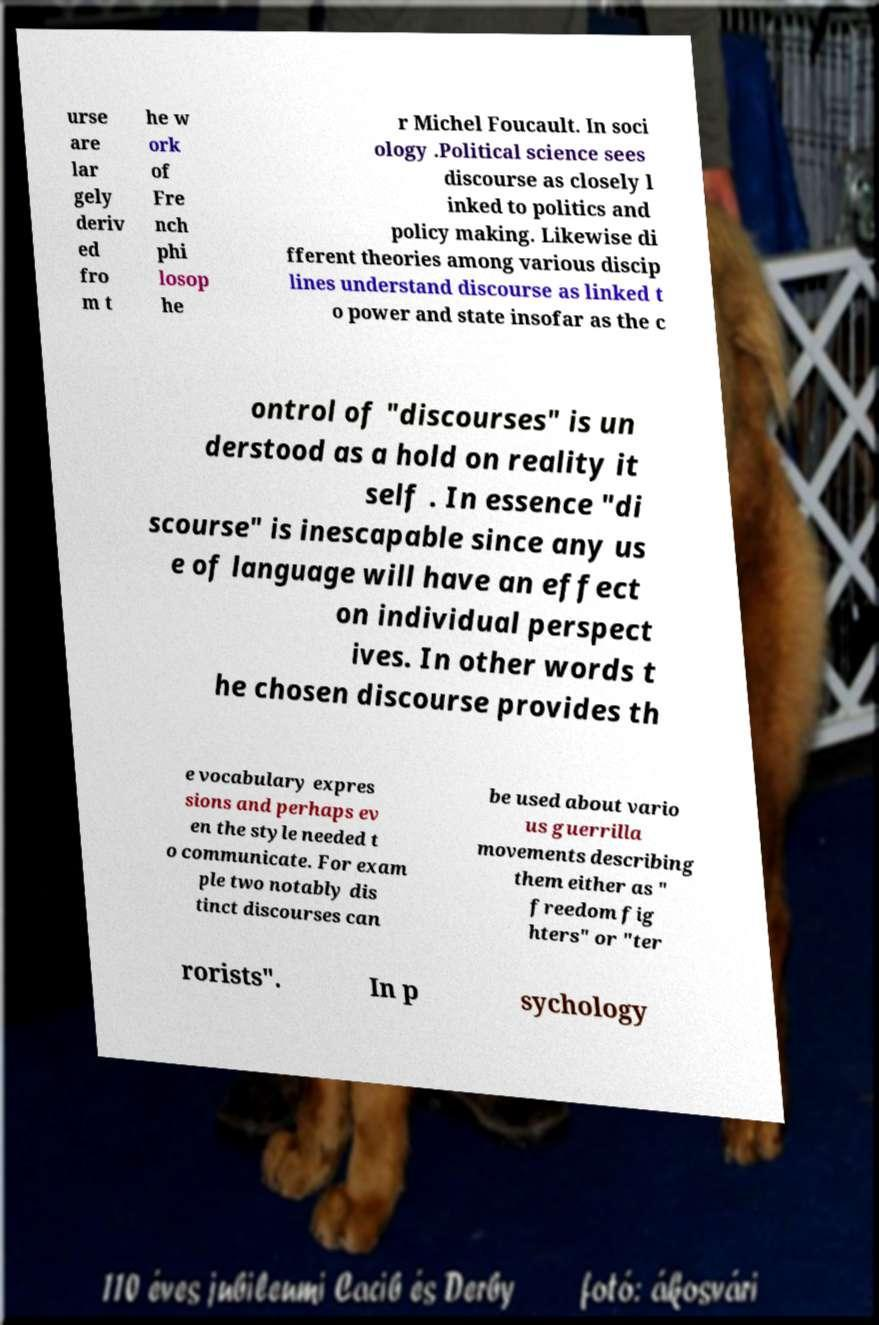Please read and relay the text visible in this image. What does it say? urse are lar gely deriv ed fro m t he w ork of Fre nch phi losop he r Michel Foucault. In soci ology .Political science sees discourse as closely l inked to politics and policy making. Likewise di fferent theories among various discip lines understand discourse as linked t o power and state insofar as the c ontrol of "discourses" is un derstood as a hold on reality it self . In essence "di scourse" is inescapable since any us e of language will have an effect on individual perspect ives. In other words t he chosen discourse provides th e vocabulary expres sions and perhaps ev en the style needed t o communicate. For exam ple two notably dis tinct discourses can be used about vario us guerrilla movements describing them either as " freedom fig hters" or "ter rorists". In p sychology 